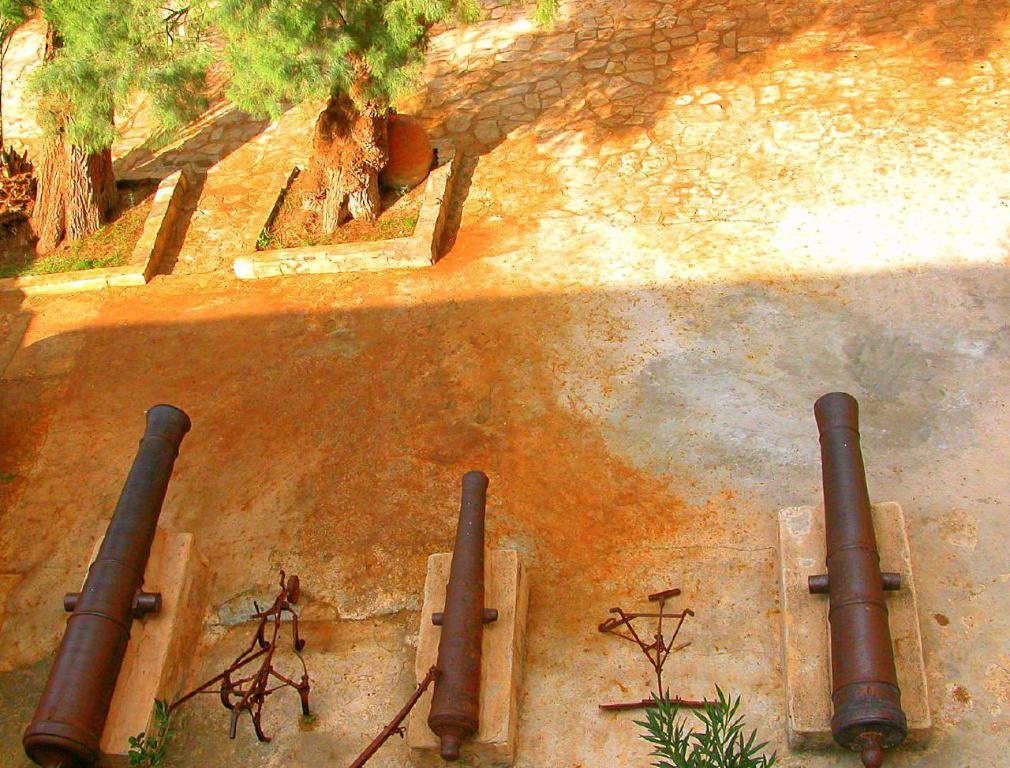What objects are present on the ground in the image? There are three cannons in the image. Where are the cannons located in relation to the trees? The trees are at the top of the image, while the cannons are on the ground. What type of glue is being used to hold the zoo animals together in the image? There is no zoo or animals present in the image, and therefore no glue or need for it. 